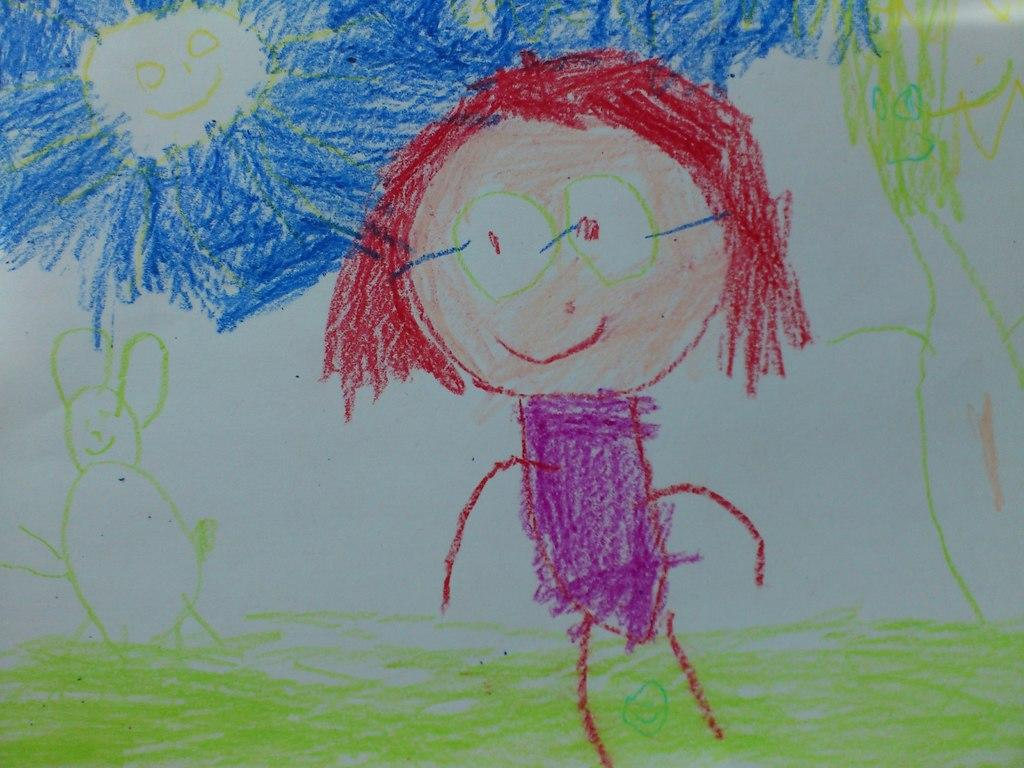What is the main subject of the image? The main subject of the image is a drawing on a white surface. What can be observed about the colors used in the drawing? The drawing consists of multiple colors. What types of objects are depicted in the drawing? The drawing depicts various objects. How does the mitten help the person in the image? There is no mitten present in the image, so it cannot help anyone in the image. What type of pain is being experienced by the person in the image? There is no person present in the image, so it is impossible to determine if they are experiencing any pain. 